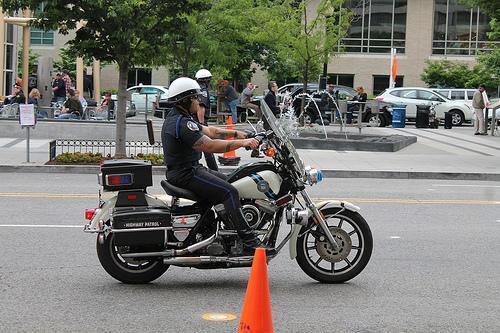How many policemen are wearing helmets?
Give a very brief answer. 2. 